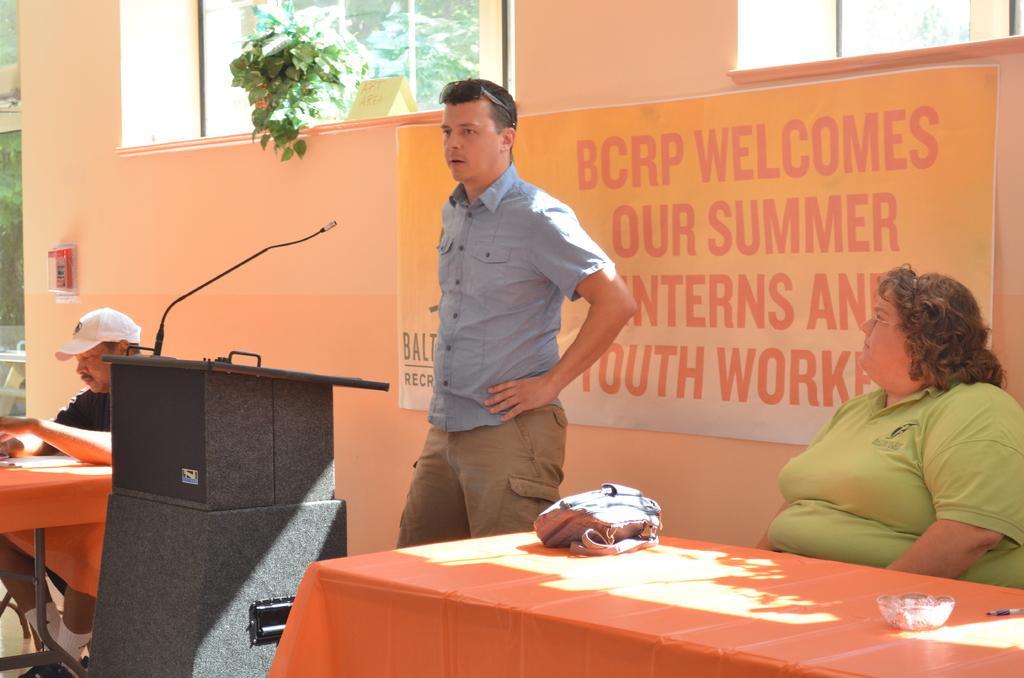How would you summarize this image in a sentence or two? In this image I see 3 persons, in which 2 of them are men and another is a woman. I can also see 2 of them are sitting and this man is standing in front of a podium. In the background I see the wall, banner and a plant over here. 